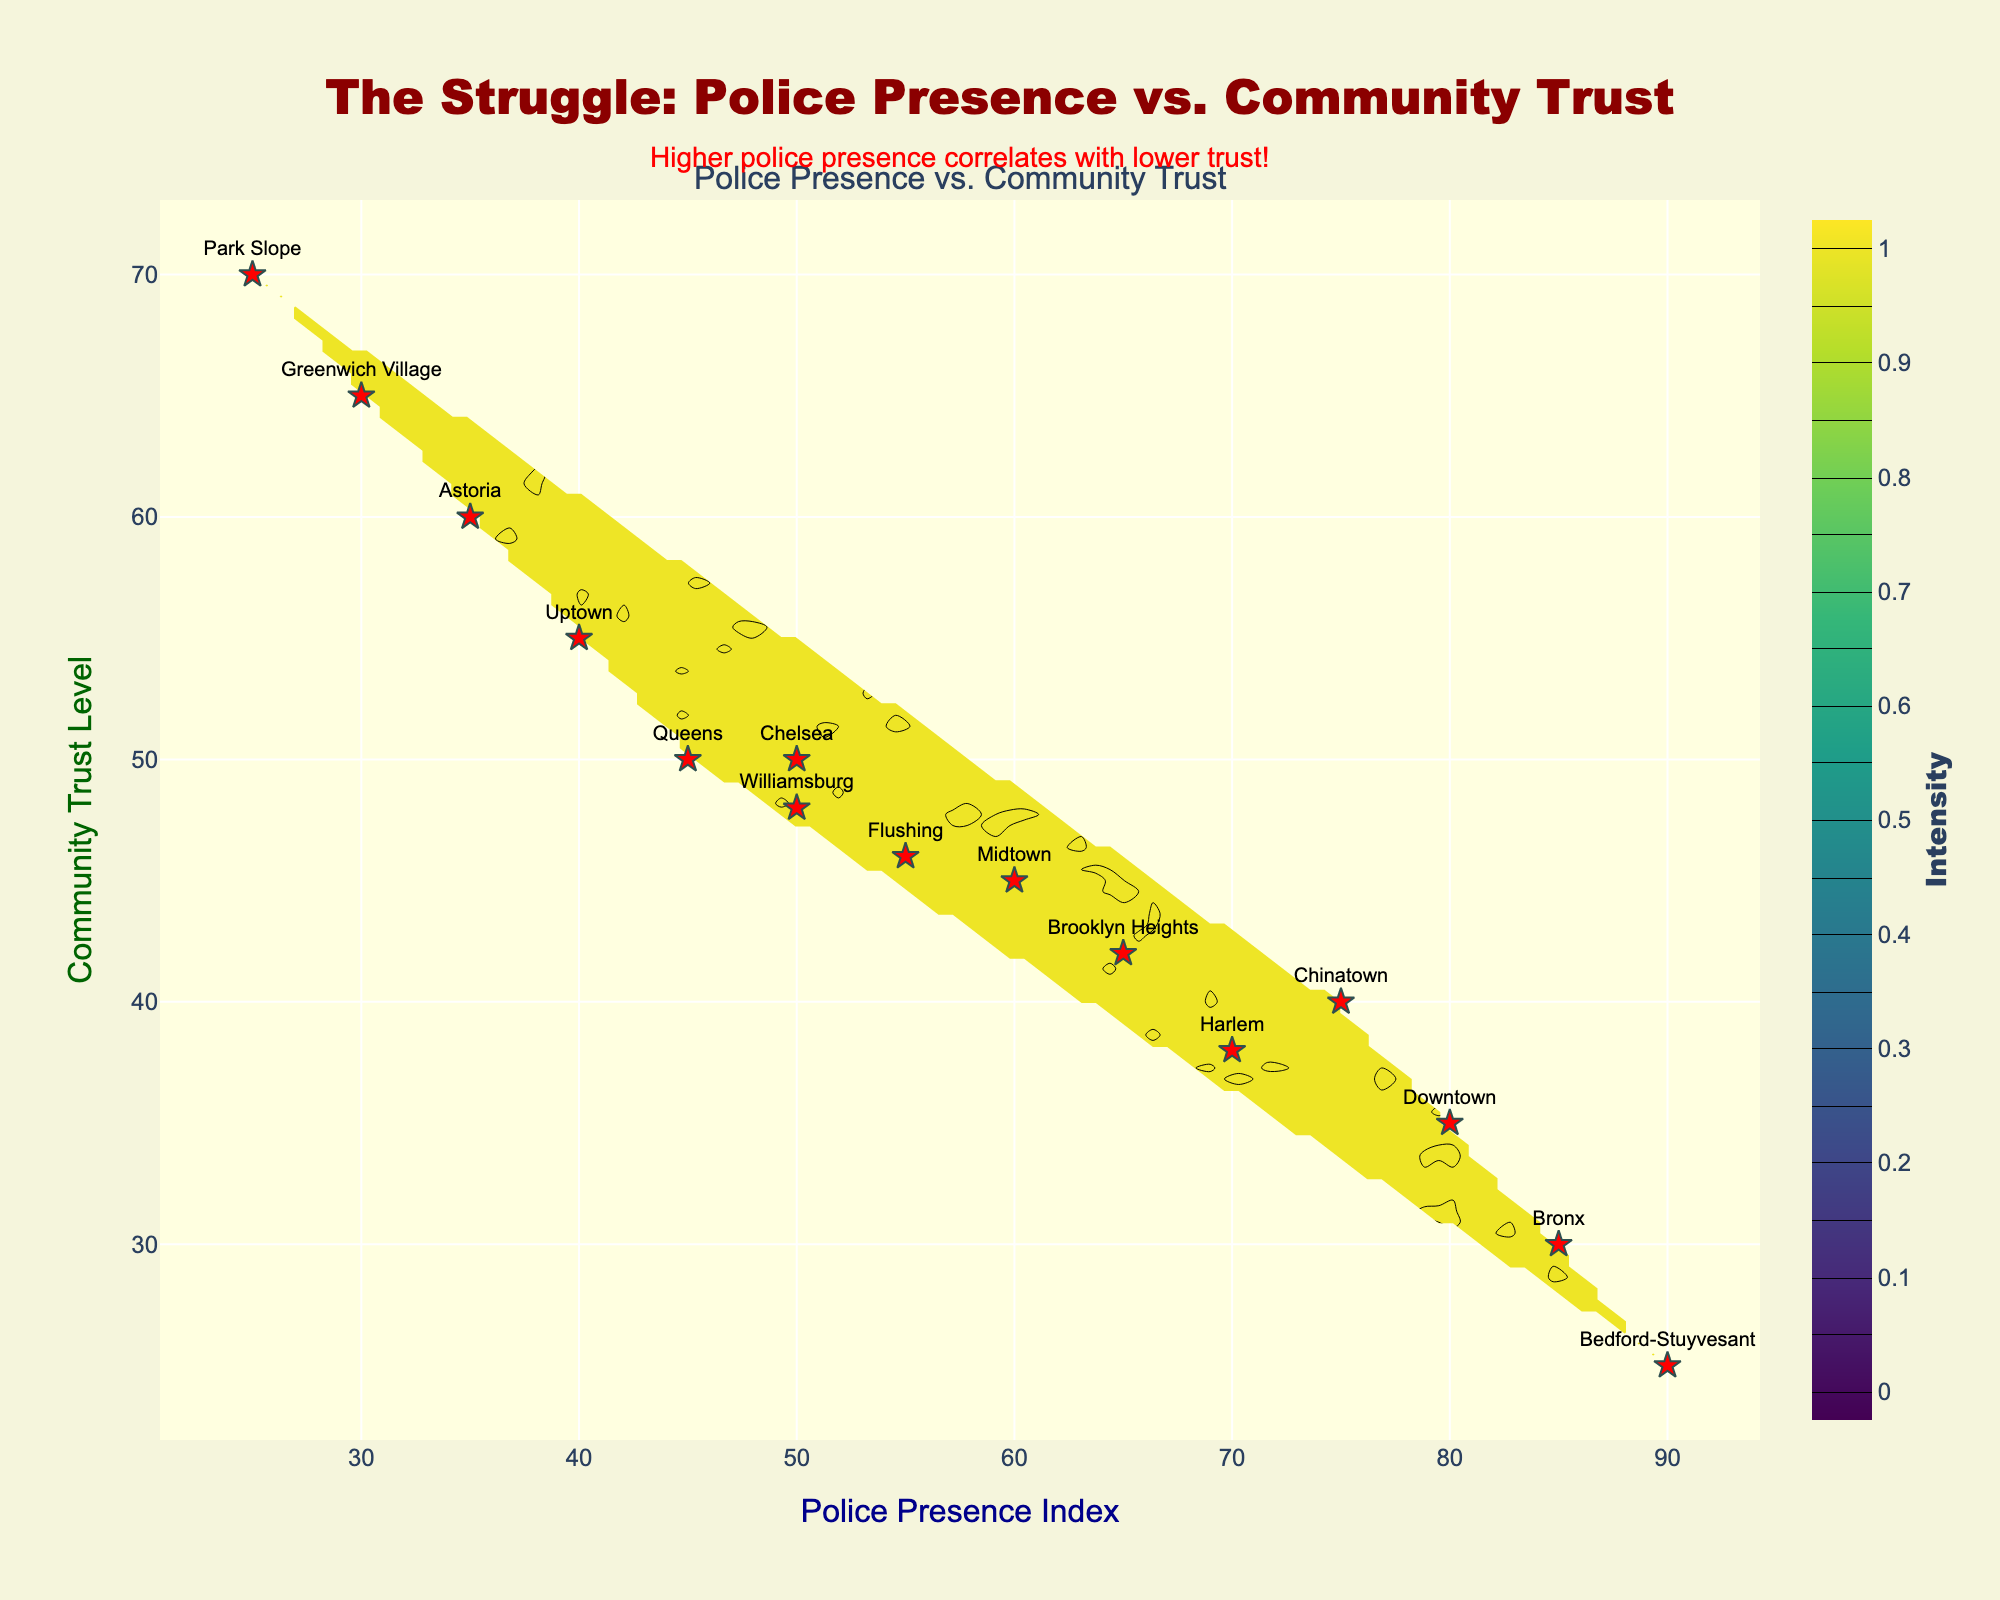What is the title of the figure? The title is placed at the top center of the figure and is formatted in large dark red text. It is the most prominently displayed text on the plot.
Answer: "The Struggle: Police Presence vs. Community Trust" What do the x-axis and y-axis represent? The labels of the axes tell us what they measure: the x-axis represents the "Police Presence Index", and the y-axis represents the "Community Trust Level".
Answer: Police Presence Index and Community Trust Level How many neighborhoods are plotted on the figure? By counting the markers on the scatter plot, we can determine the number of neighborhoods. Each marker represents one neighborhood.
Answer: 15 Which neighborhood has the highest Police Presence Index? By looking at the x-axis values of the neighborhoods, we see that Bedford-Stuyvesant has a Police Presence Index of 90, which is the highest.
Answer: Bedford-Stuyvesant Which neighborhood has the highest Community Trust Level? By looking at the y-axis values of the neighborhoods, we see that Park Slope has a Community Trust Level of 70, which is the highest.
Answer: Park Slope What pattern do you observe between police presence and community trust? The overall trend in the contour plot shows that areas with higher police presence tend to have lower community trust levels, as indicated by the plotting of higher density areas of darker color corresponding to lower trust values. This is also highlighted by the annotation on the plot.
Answer: Higher police presence correlates with lower community trust Which neighborhoods have both Police Presence Index and Community Trust Level closest to 50? From the plot, we can identify the neighborhoods with both values around the middle. Chelsea and Williamsburg both have values around 50 for both parameters.
Answer: Chelsea and Williamsburg How does the Community Trust Level compare between Downtown and Bronx? Compare the y-axis values of the two neighborhoods: Downtown has a Community Trust Level of 35, while Bronx has 30.
Answer: Downtown has a higher Trust Level than Bronx Which neighborhood displays the greatest disparity between Police Presence Index and Community Trust Level? The neighborhood with the most significant difference between the two indices can be identified by comparing the plotted points: Bedford-Stuyvesant shows the largest disparity with a Police Presence Index of 90 and a Community Trust Level of 25.
Answer: Bedford-Stuyvesant What color is mainly used in the contour plot to indicate the highest density regions? The color scale used in the contour plot, Viridis, changes from dark purple to yellow, with yellow indicating areas of highest density. These colors represent the intensity levels on the color bar legend.
Answer: Yellow 